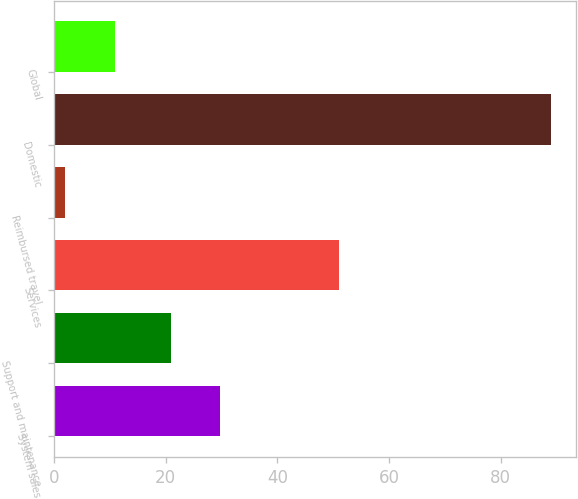<chart> <loc_0><loc_0><loc_500><loc_500><bar_chart><fcel>System sales<fcel>Support and maintenance<fcel>Services<fcel>Reimbursed travel<fcel>Domestic<fcel>Global<nl><fcel>29.7<fcel>21<fcel>51<fcel>2<fcel>89<fcel>11<nl></chart> 